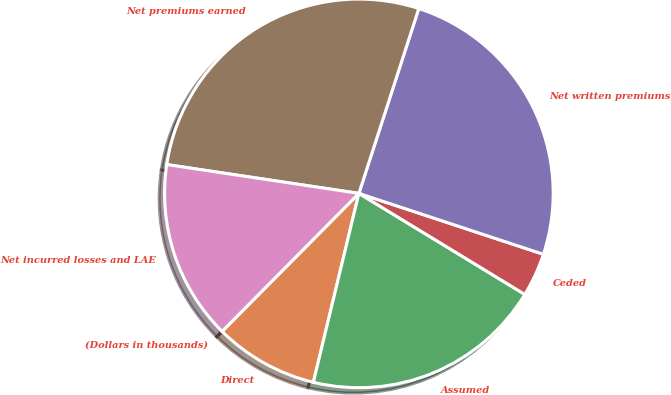Convert chart. <chart><loc_0><loc_0><loc_500><loc_500><pie_chart><fcel>(Dollars in thousands)<fcel>Direct<fcel>Assumed<fcel>Ceded<fcel>Net written premiums<fcel>Net premiums earned<fcel>Net incurred losses and LAE<nl><fcel>0.01%<fcel>8.66%<fcel>20.06%<fcel>3.63%<fcel>25.09%<fcel>27.62%<fcel>14.94%<nl></chart> 